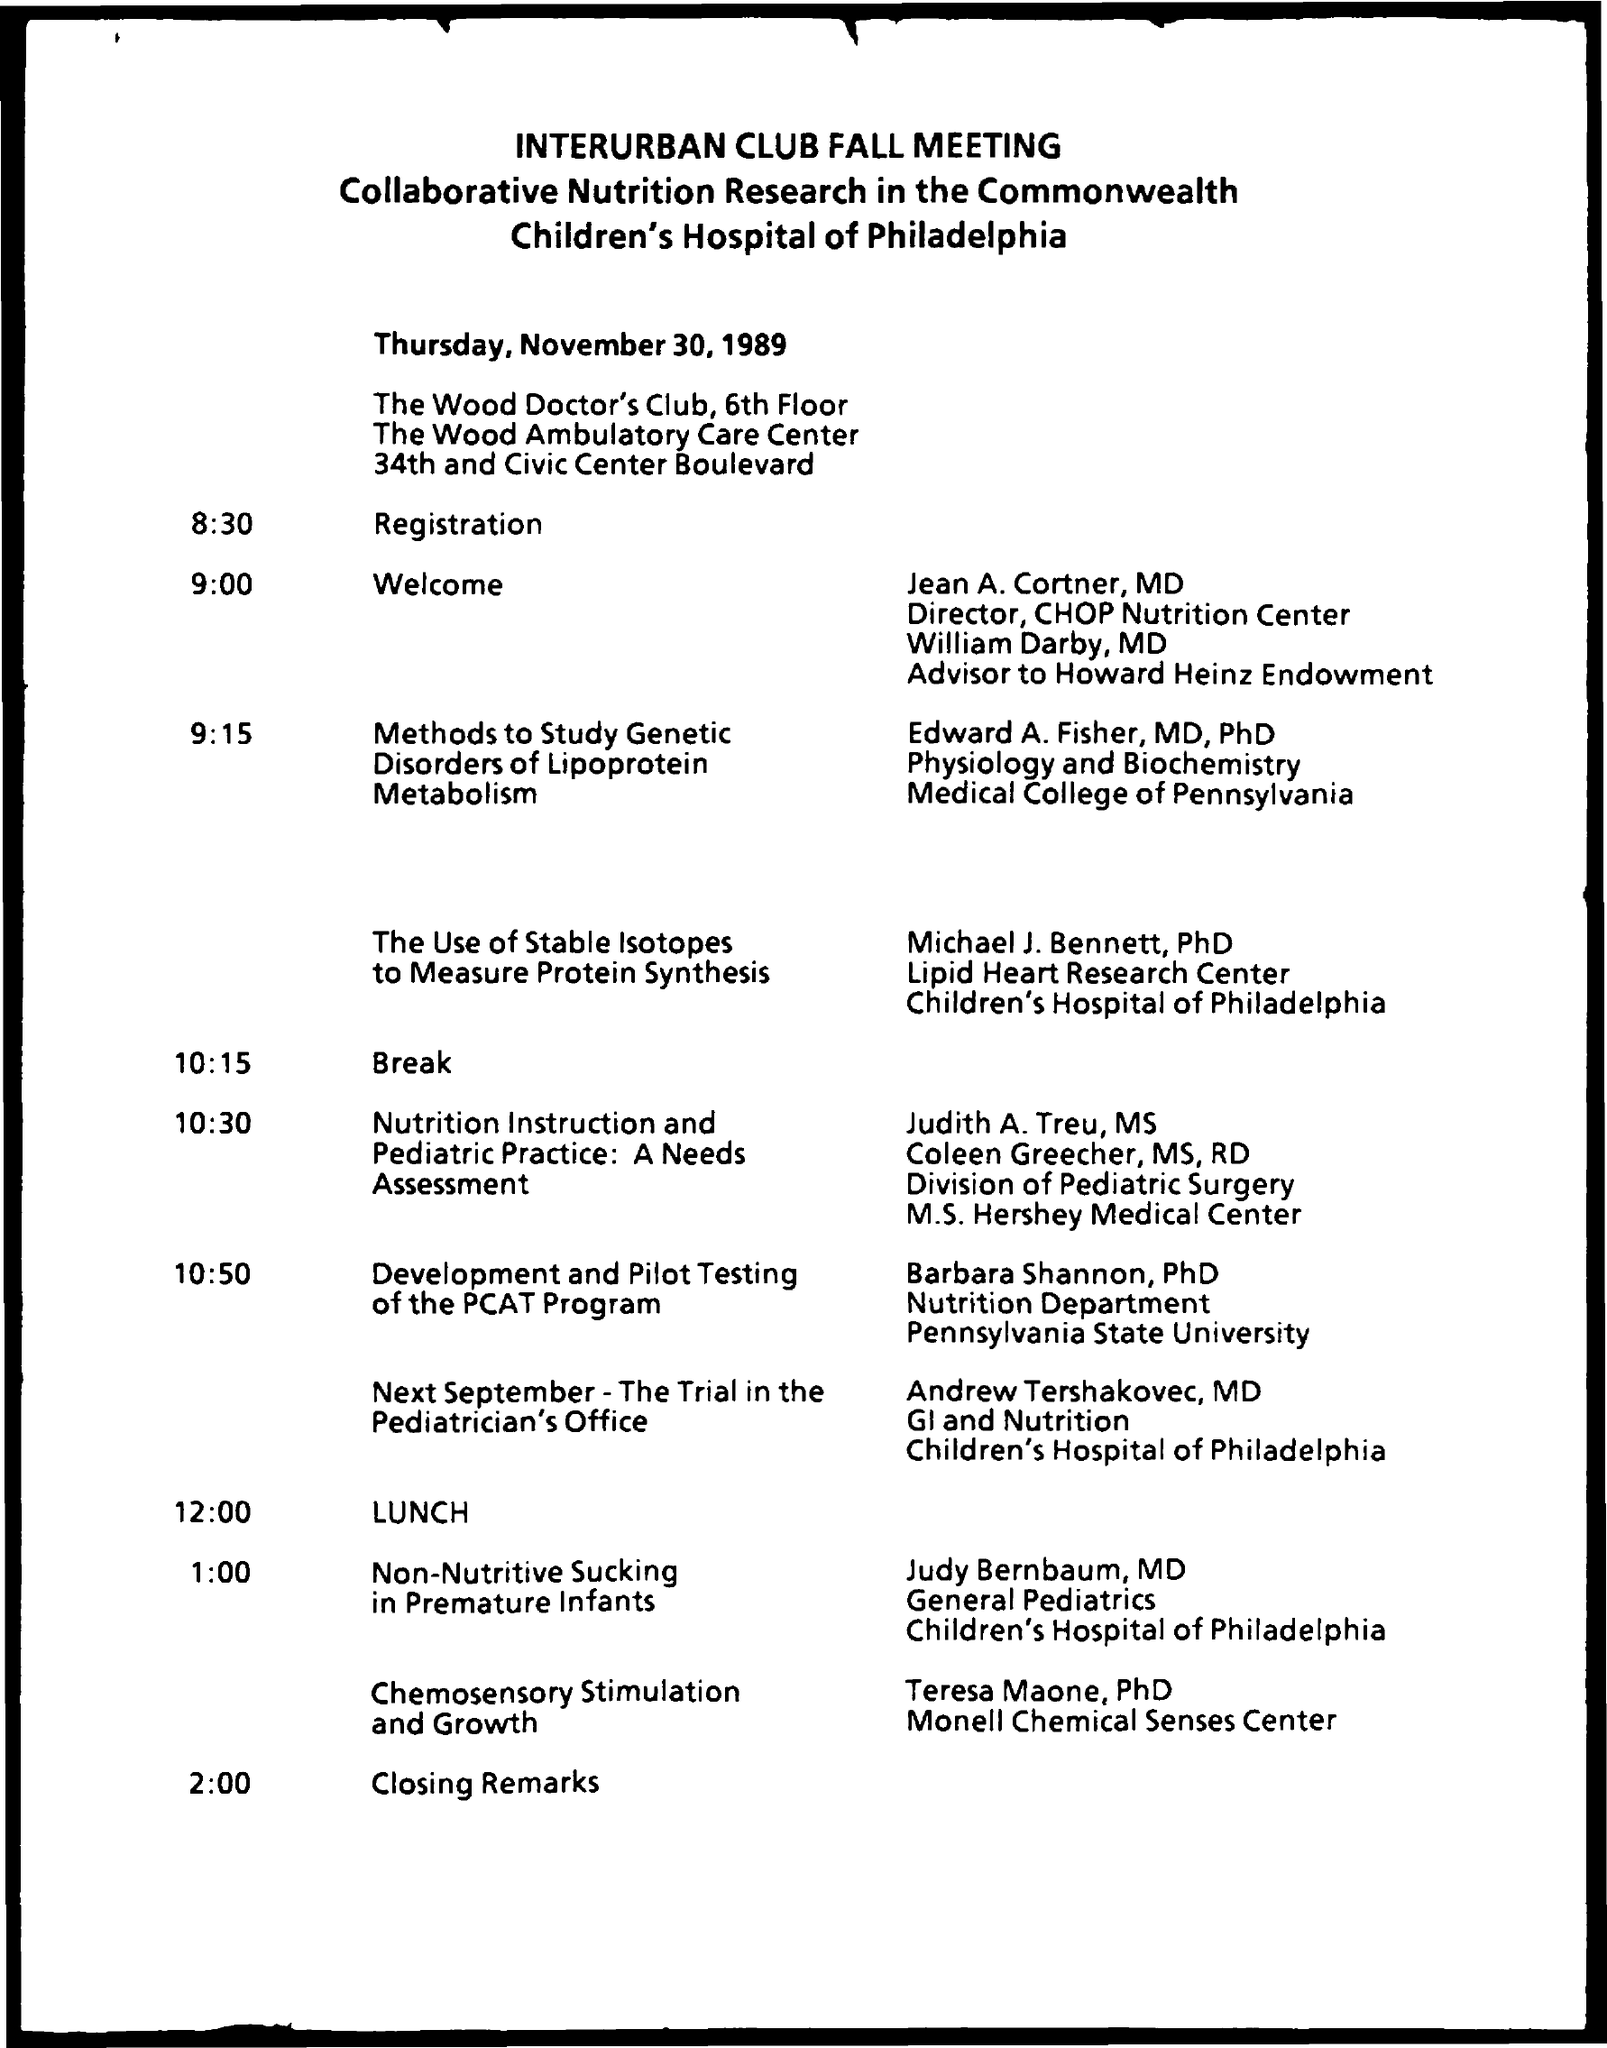What is the name of the meeting mentioned in the given page ?
Offer a very short reply. Interurban club fall meeting. What is the date mentioned in the given page ?
Your answer should be very brief. Thursday, November 30, 1989. What is the schedule at the time of 8:30 ?
Make the answer very short. Registration. What is the given schedule at the time of 9:00 ?
Your answer should be very brief. Welcome. What is the given schedule at the time of 10:15 ?
Give a very brief answer. Break. What is the schedule at the time of 12:00 ?
Provide a short and direct response. Lunch. What is the schedule at the time of 2:00 ?
Ensure brevity in your answer.  Closing remarks. 